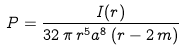<formula> <loc_0><loc_0><loc_500><loc_500>P = \frac { I ( r ) } { 3 2 \, \pi \, { r } ^ { 5 } { a } ^ { 8 } \left ( r - 2 \, m \right ) }</formula> 